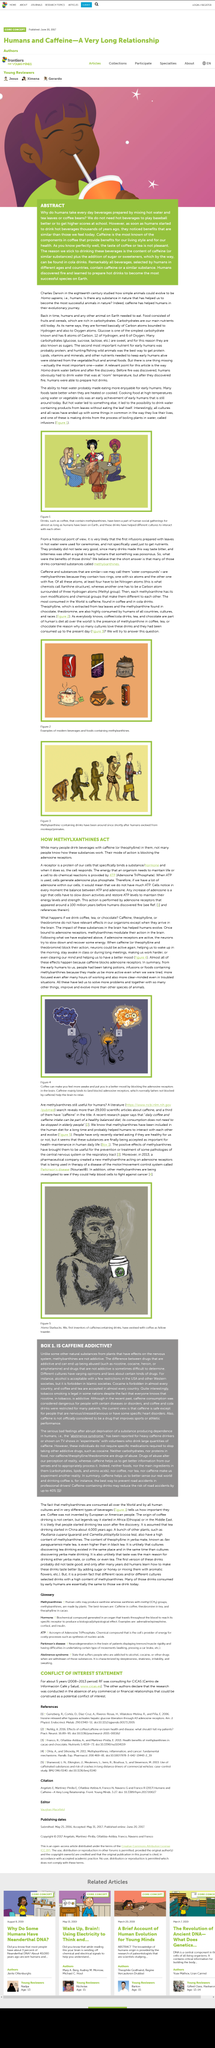Highlight a few significant elements in this photo. After hypoxia, the molecule inosine is released and it activates the liberation of glucose from the liver through the A3 adenosine receptors. The acronym CICAS stands for "Centro de Información Café y Salud," which is a center for information about coffee and health. 